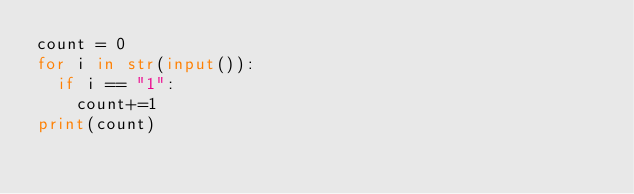Convert code to text. <code><loc_0><loc_0><loc_500><loc_500><_Python_>count = 0
for i in str(input()):
  if i == "1":
    count+=1    
print(count)</code> 